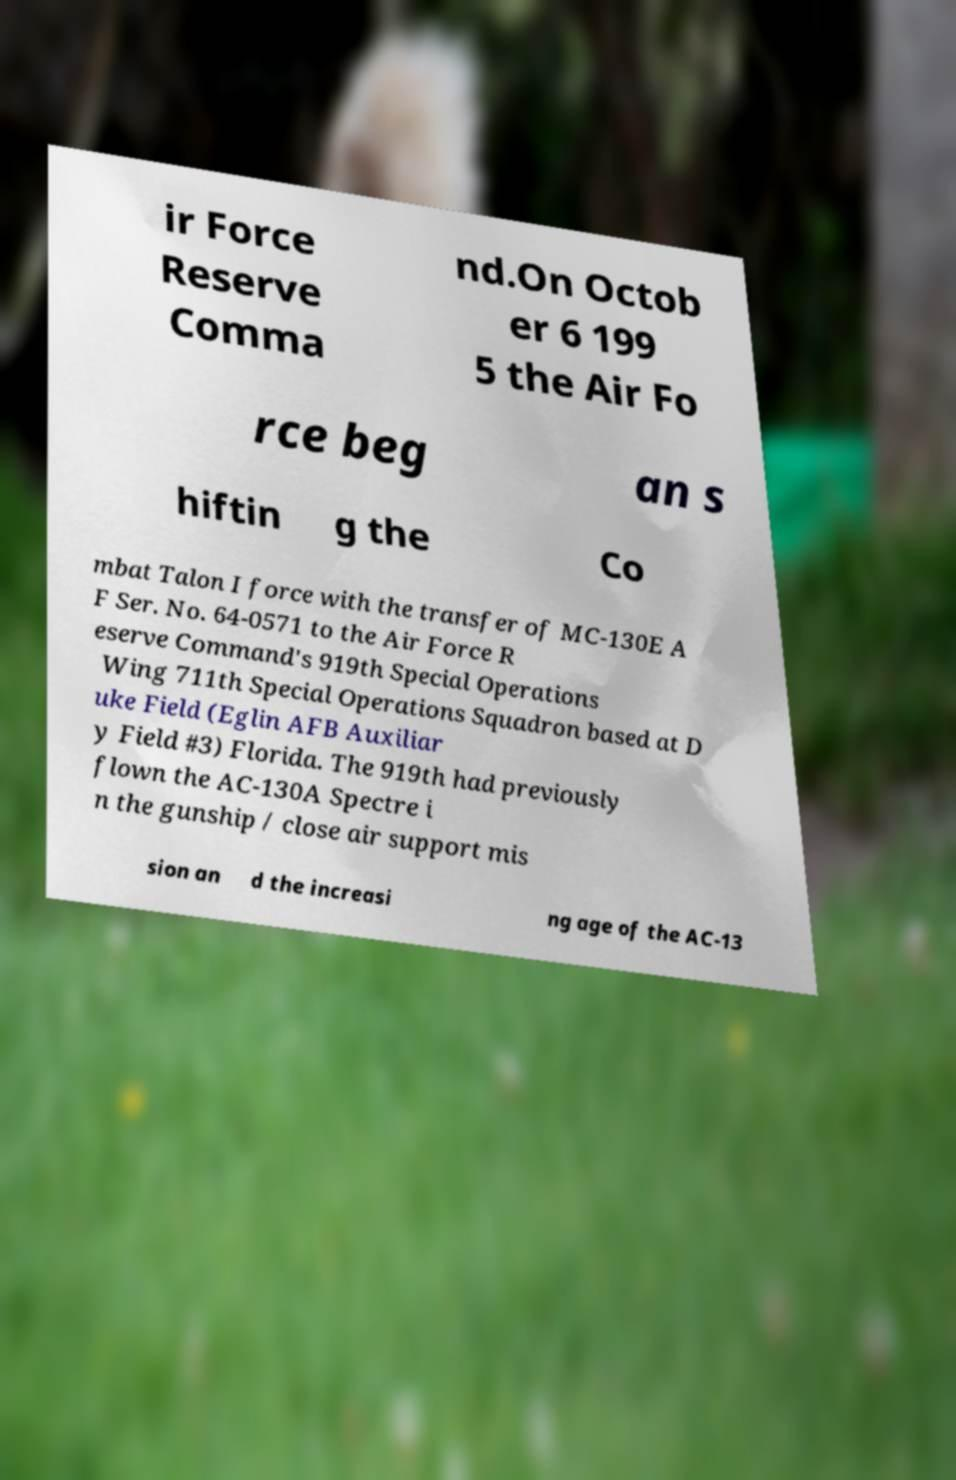Can you accurately transcribe the text from the provided image for me? ir Force Reserve Comma nd.On Octob er 6 199 5 the Air Fo rce beg an s hiftin g the Co mbat Talon I force with the transfer of MC-130E A F Ser. No. 64-0571 to the Air Force R eserve Command's 919th Special Operations Wing 711th Special Operations Squadron based at D uke Field (Eglin AFB Auxiliar y Field #3) Florida. The 919th had previously flown the AC-130A Spectre i n the gunship / close air support mis sion an d the increasi ng age of the AC-13 